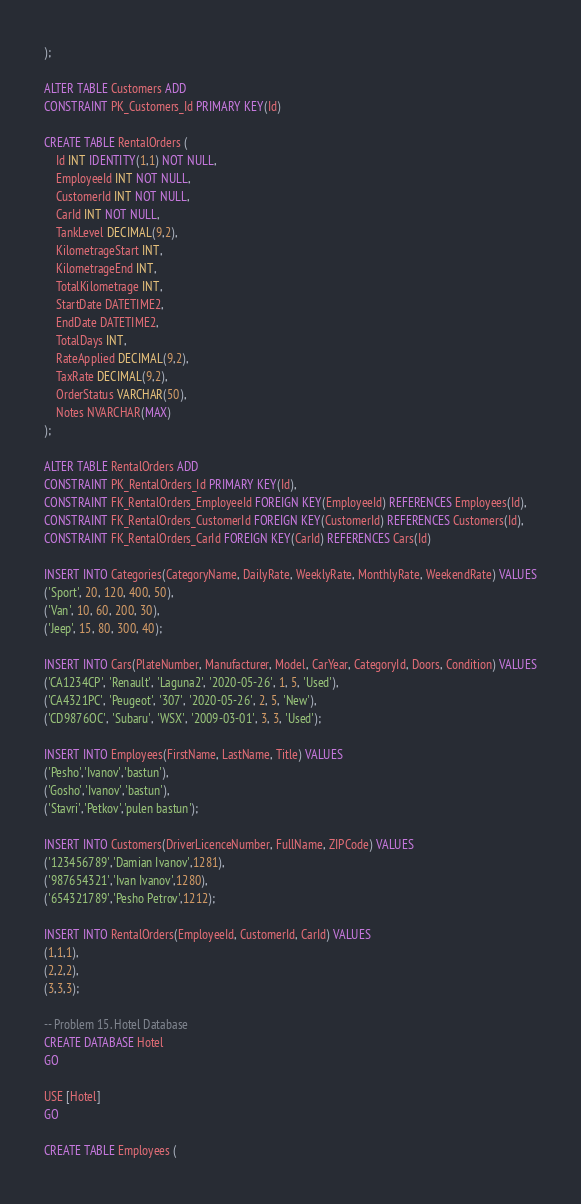<code> <loc_0><loc_0><loc_500><loc_500><_SQL_>);

ALTER TABLE Customers ADD
CONSTRAINT PK_Customers_Id PRIMARY KEY(Id)

CREATE TABLE RentalOrders (
	Id INT IDENTITY(1,1) NOT NULL,
	EmployeeId INT NOT NULL,
	CustomerId INT NOT NULL,
	CarId INT NOT NULL,
	TankLevel DECIMAL(9,2),
	KilometrageStart INT, 
	KilometrageEnd INT, 
	TotalKilometrage INT, 
	StartDate DATETIME2, 
	EndDate DATETIME2, 
	TotalDays INT,
	RateApplied DECIMAL(9,2), 
	TaxRate DECIMAL(9,2), 
	OrderStatus VARCHAR(50),
	Notes NVARCHAR(MAX)
);

ALTER TABLE RentalOrders ADD
CONSTRAINT PK_RentalOrders_Id PRIMARY KEY(Id),
CONSTRAINT FK_RentalOrders_EmployeeId FOREIGN KEY(EmployeeId) REFERENCES Employees(Id),
CONSTRAINT FK_RentalOrders_CustomerId FOREIGN KEY(CustomerId) REFERENCES Customers(Id),
CONSTRAINT FK_RentalOrders_CarId FOREIGN KEY(CarId) REFERENCES Cars(Id)

INSERT INTO Categories(CategoryName, DailyRate, WeeklyRate, MonthlyRate, WeekendRate) VALUES
('Sport', 20, 120, 400, 50),
('Van', 10, 60, 200, 30),
('Jeep', 15, 80, 300, 40);

INSERT INTO Cars(PlateNumber, Manufacturer, Model, CarYear, CategoryId, Doors, Condition) VALUES
('CA1234CP', 'Renault', 'Laguna2', '2020-05-26', 1, 5, 'Used'),
('CA4321PC', 'Peugeot', '307', '2020-05-26', 2, 5, 'New'),
('CD9876OC', 'Subaru', 'WSX', '2009-03-01', 3, 3, 'Used');

INSERT INTO Employees(FirstName, LastName, Title) VALUES
('Pesho','Ivanov','bastun'),
('Gosho','Ivanov','bastun'),
('Stavri','Petkov','pulen bastun');

INSERT INTO Customers(DriverLicenceNumber, FullName, ZIPCode) VALUES
('123456789','Damian Ivanov',1281),
('987654321','Ivan Ivanov',1280),
('654321789','Pesho Petrov',1212);

INSERT INTO RentalOrders(EmployeeId, CustomerId, CarId) VALUES
(1,1,1),
(2,2,2),
(3,3,3);

-- Problem 15. Hotel Database
CREATE DATABASE Hotel 
GO

USE [Hotel]
GO

CREATE TABLE Employees (</code> 